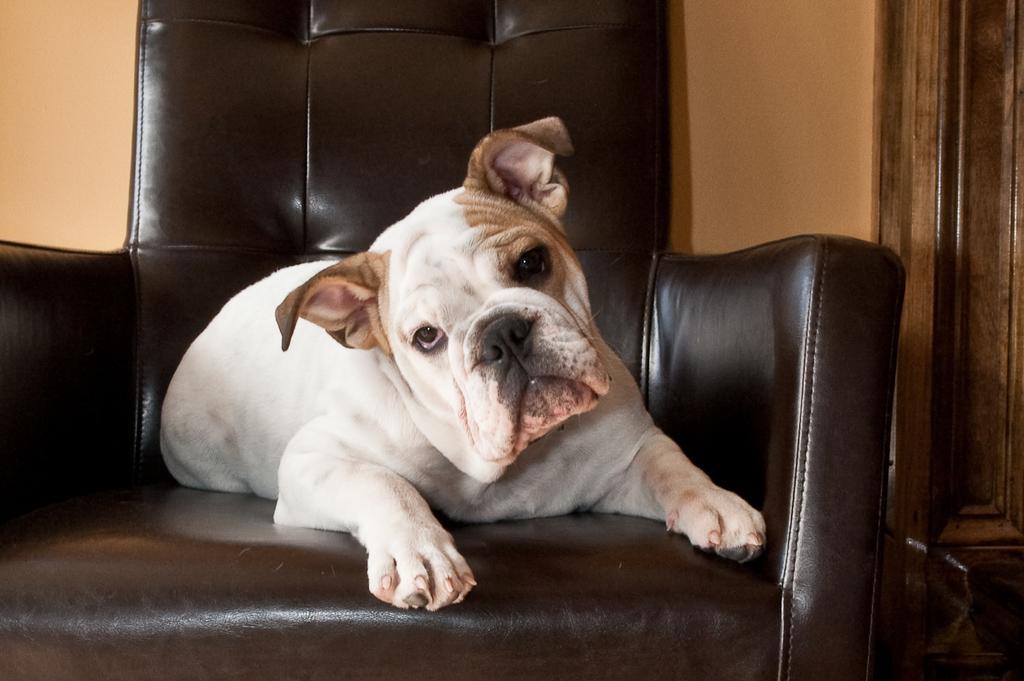Please provide a concise description of this image. A dog is sitting on the sofa chair. 